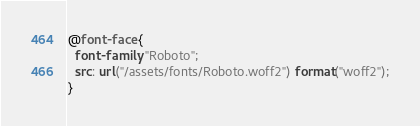<code> <loc_0><loc_0><loc_500><loc_500><_CSS_>@font-face {
  font-family: "Roboto";
  src: url("/assets/fonts/Roboto.woff2") format("woff2");
}</code> 